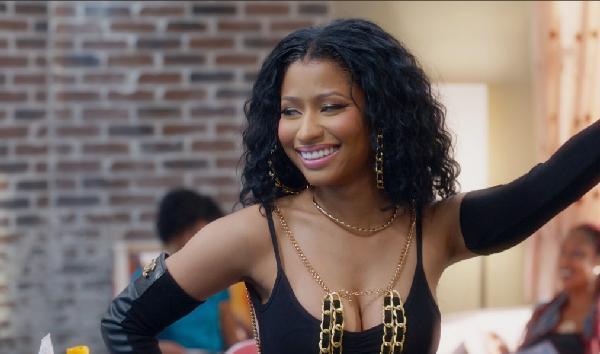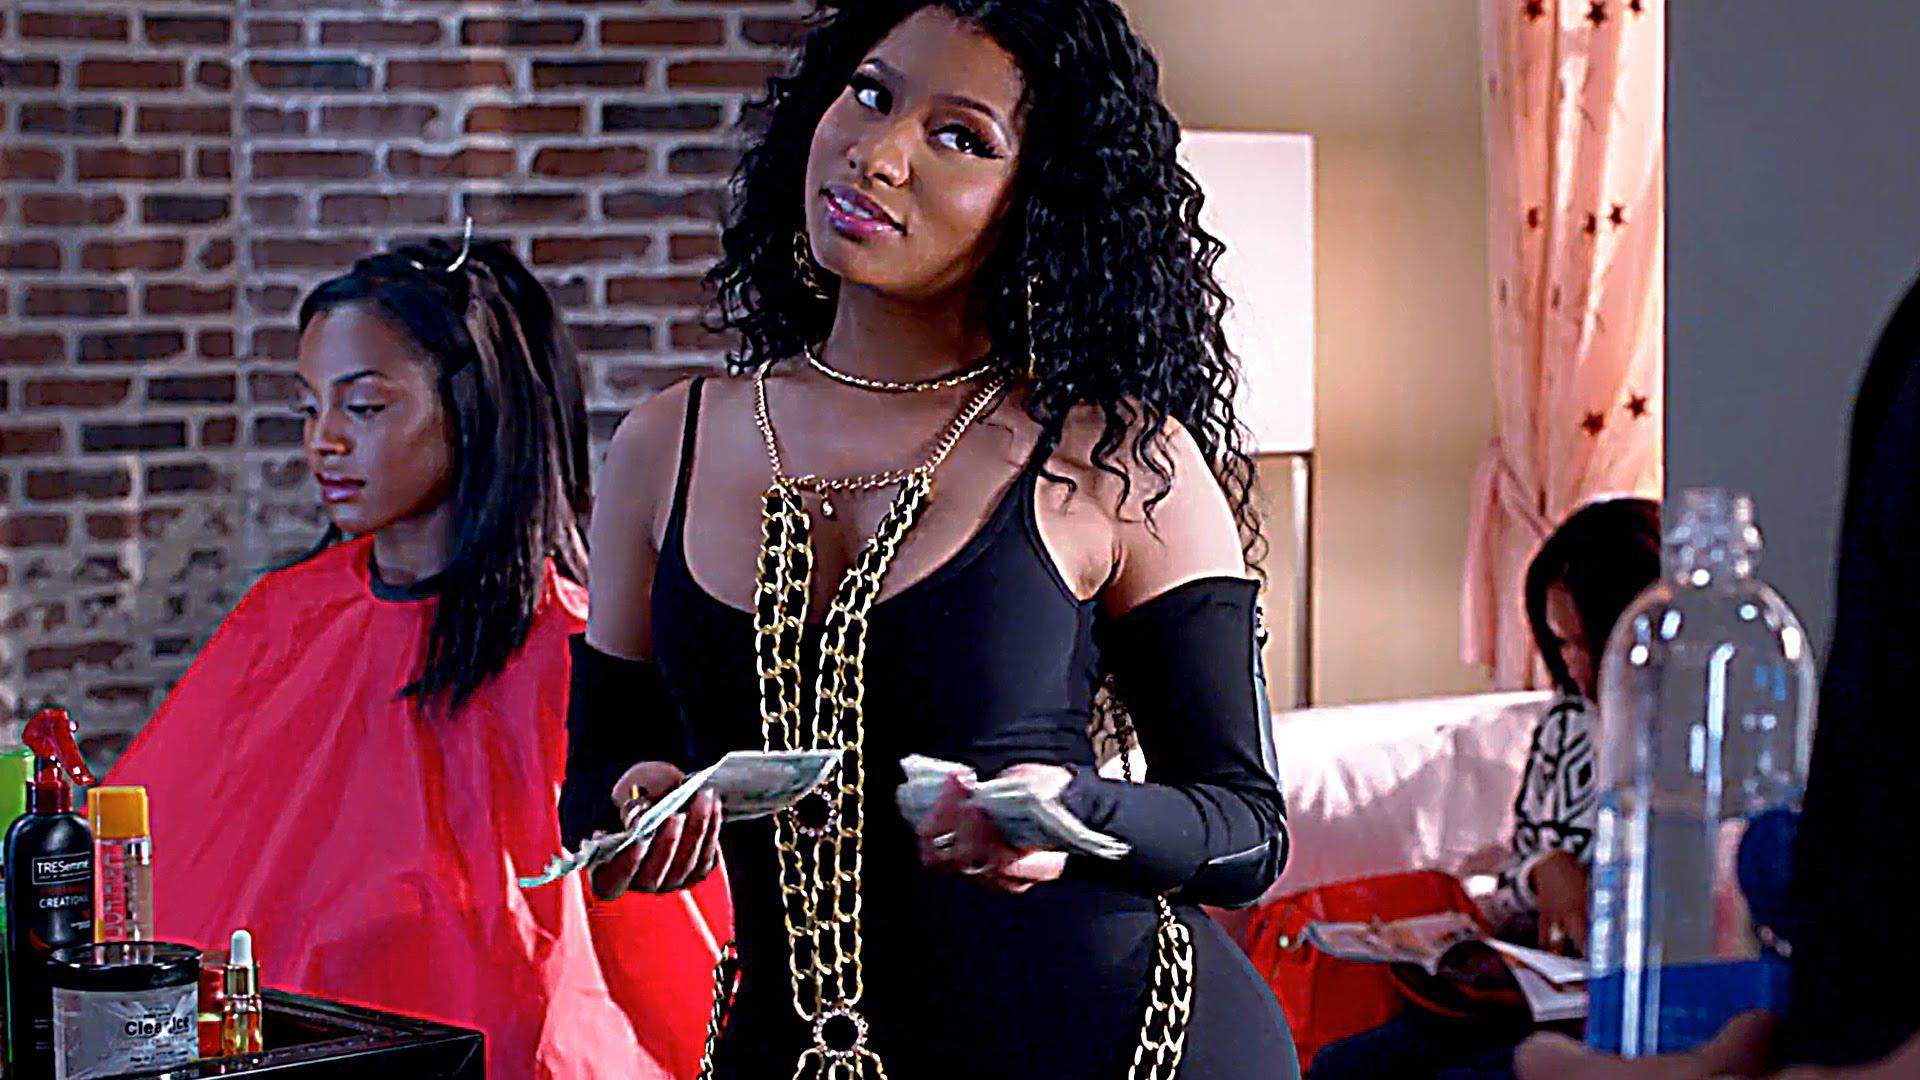The first image is the image on the left, the second image is the image on the right. For the images shown, is this caption "A woman is doing another woman's hair in only one of the images." true? Answer yes or no. No. The first image is the image on the left, the second image is the image on the right. For the images displayed, is the sentence "Left image shows a stylist behind a customer wearing a red smock, and right image shows a front-facing woman who is not styling hair." factually correct? Answer yes or no. No. 